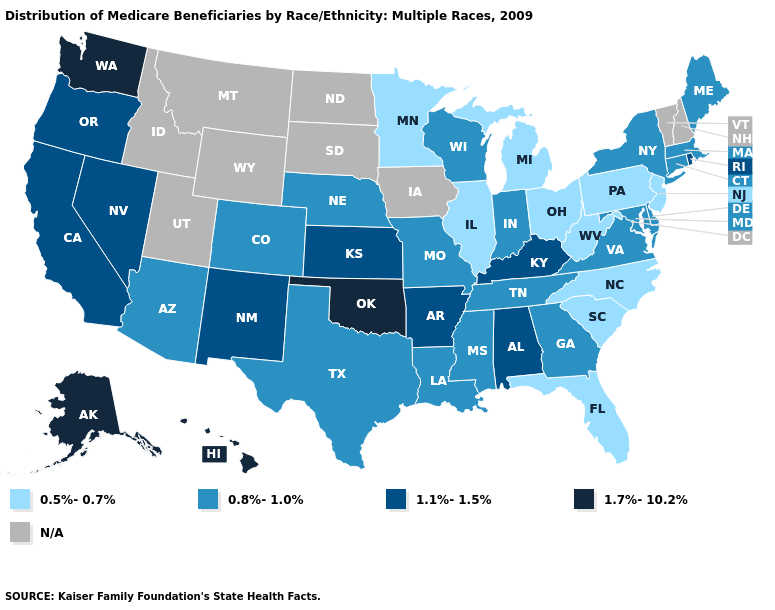Name the states that have a value in the range N/A?
Concise answer only. Idaho, Iowa, Montana, New Hampshire, North Dakota, South Dakota, Utah, Vermont, Wyoming. Name the states that have a value in the range 1.7%-10.2%?
Give a very brief answer. Alaska, Hawaii, Oklahoma, Washington. Name the states that have a value in the range N/A?
Give a very brief answer. Idaho, Iowa, Montana, New Hampshire, North Dakota, South Dakota, Utah, Vermont, Wyoming. How many symbols are there in the legend?
Concise answer only. 5. What is the value of New York?
Write a very short answer. 0.8%-1.0%. Does Michigan have the highest value in the USA?
Give a very brief answer. No. What is the value of South Carolina?
Write a very short answer. 0.5%-0.7%. What is the value of Idaho?
Short answer required. N/A. Name the states that have a value in the range 0.8%-1.0%?
Write a very short answer. Arizona, Colorado, Connecticut, Delaware, Georgia, Indiana, Louisiana, Maine, Maryland, Massachusetts, Mississippi, Missouri, Nebraska, New York, Tennessee, Texas, Virginia, Wisconsin. What is the value of North Dakota?
Write a very short answer. N/A. Among the states that border Oklahoma , which have the lowest value?
Keep it brief. Colorado, Missouri, Texas. Name the states that have a value in the range 1.1%-1.5%?
Short answer required. Alabama, Arkansas, California, Kansas, Kentucky, Nevada, New Mexico, Oregon, Rhode Island. 